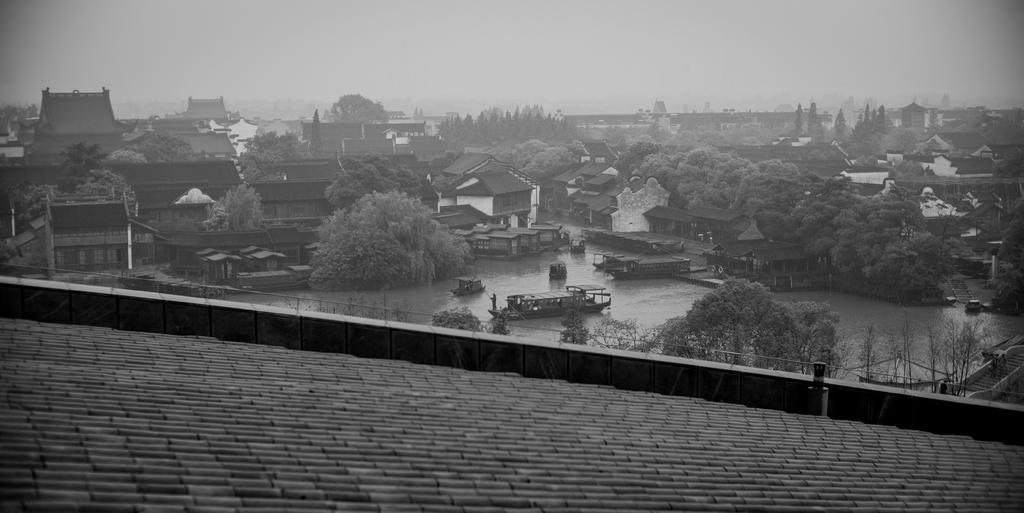How would you summarize this image in a sentence or two? This image consists of many houses and trees. At the bottom, there is water and we can see the boats. In the front, there is a roof. 